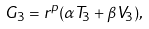<formula> <loc_0><loc_0><loc_500><loc_500>G _ { 3 } = r ^ { p } ( \alpha T _ { 3 } + \beta V _ { 3 } ) ,</formula> 